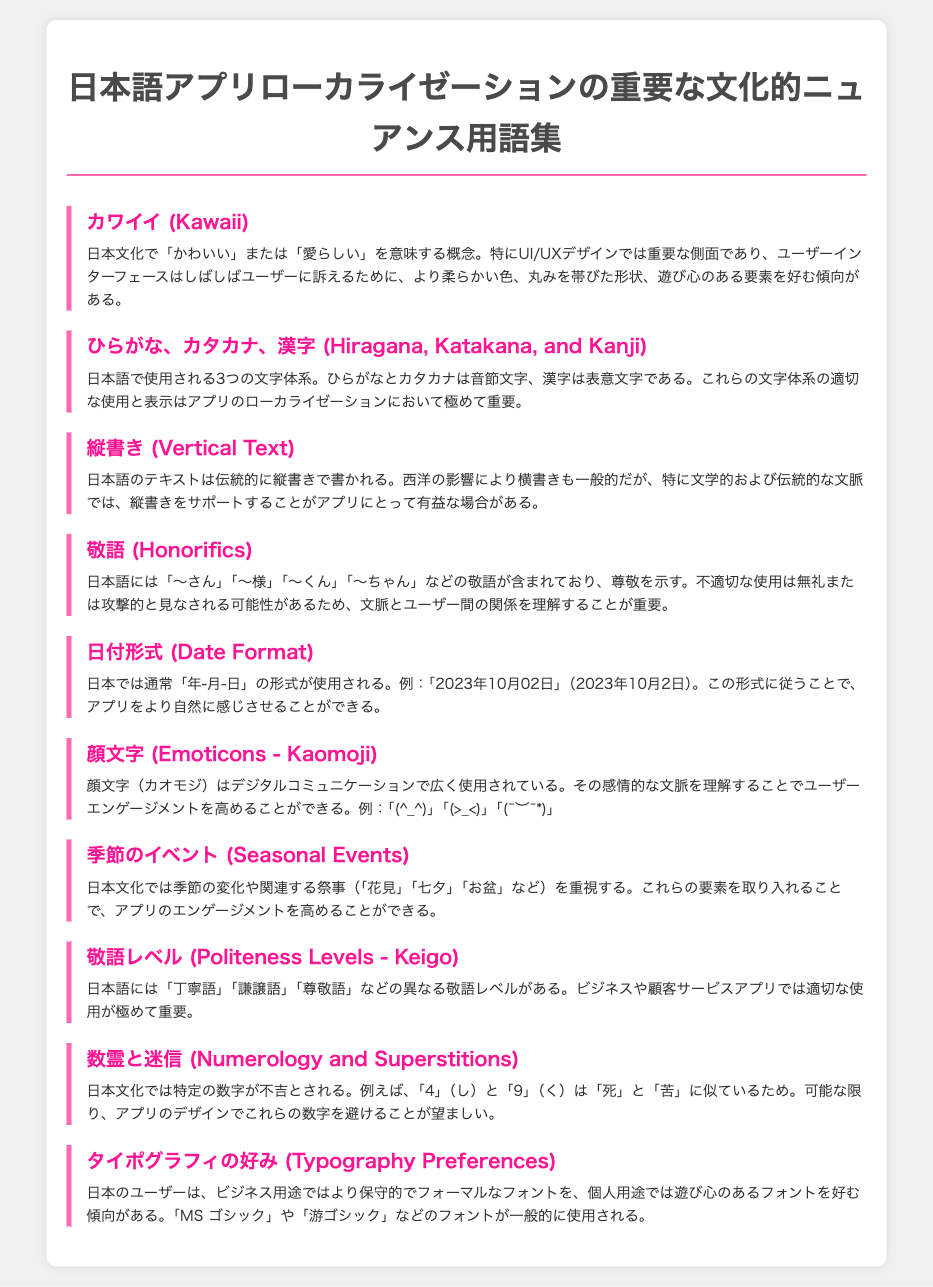What is the term that means "cute" in Japanese culture? The document defines "カワイイ (Kawaii)" as a concept meaning "cute" or "adorable" in Japanese culture.
Answer: カワイイ (Kawaii) How many writing systems does Japanese use? The document mentions three writing systems: ひらがな, カタカナ, and 漢字.
Answer: 3 What is the traditional format for writing Japanese text? The document explains that Japanese text is traditionally written in vertical format, known as "縦書き."
Answer: 縦書き What are two common honorifics mentioned? The document lists honorifics such as "〜さん" and "〜様" as examples of Japanese honorifics that show respect.
Answer: 〜さん, 〜様 What format does Japan typically use for dates? The document states that the date format used in Japan is "年-月-日."
Answer: 年-月-日 What seasonal event is mentioned in the document? The document refers to several seasonal events, specifically mentioning "花見," "七夕," and "お盆."
Answer: 花見 How many levels of politeness are indicated in the document? The document specifies that there are different levels of politeness, citing "丁寧語," "謙譲語," and "尊敬語."
Answer: 3 Which number is considered unlucky in Japanese culture according to the document? The document mentions that the number "4" is seen as unlucky in Japanese culture due to its similarity to the word for death.
Answer: 4 What font type do Japanese users prefer for personal use? The document indicates that for personal use, Japanese users tend to prefer playful fonts.
Answer: 遊び心のあるフォント 